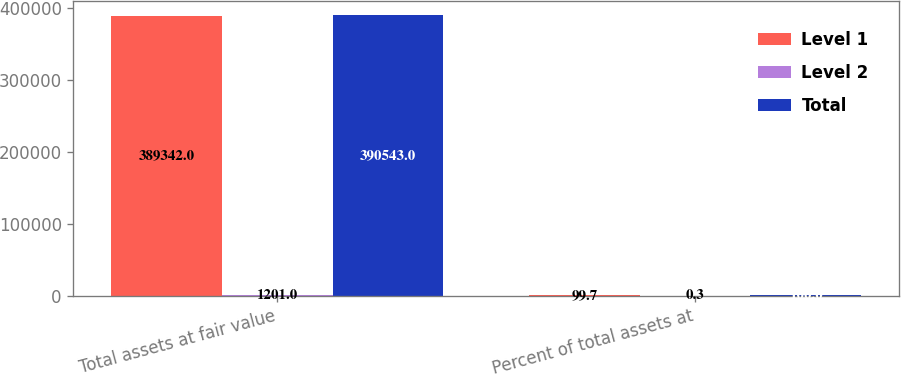Convert chart to OTSL. <chart><loc_0><loc_0><loc_500><loc_500><stacked_bar_chart><ecel><fcel>Total assets at fair value<fcel>Percent of total assets at<nl><fcel>Level 1<fcel>389342<fcel>99.7<nl><fcel>Level 2<fcel>1201<fcel>0.3<nl><fcel>Total<fcel>390543<fcel>100<nl></chart> 